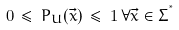<formula> <loc_0><loc_0><loc_500><loc_500>0 \, \leq \, P _ { U } ( \vec { x } ) \, \leq \, 1 \, \forall \vec { x } \in \Sigma ^ { ^ { * } }</formula> 